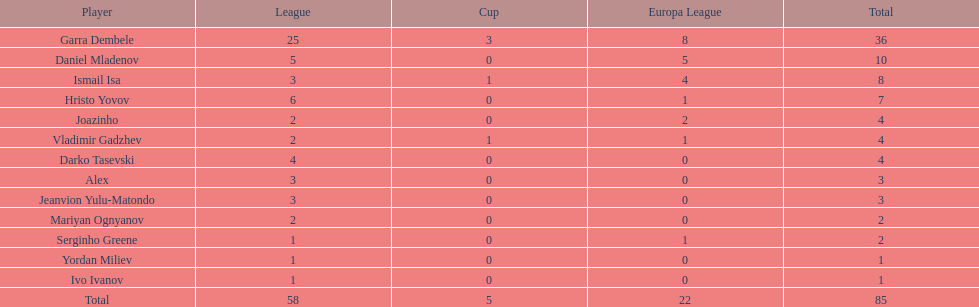Which players have at least 4 in the europa league? Garra Dembele, Daniel Mladenov, Ismail Isa. 